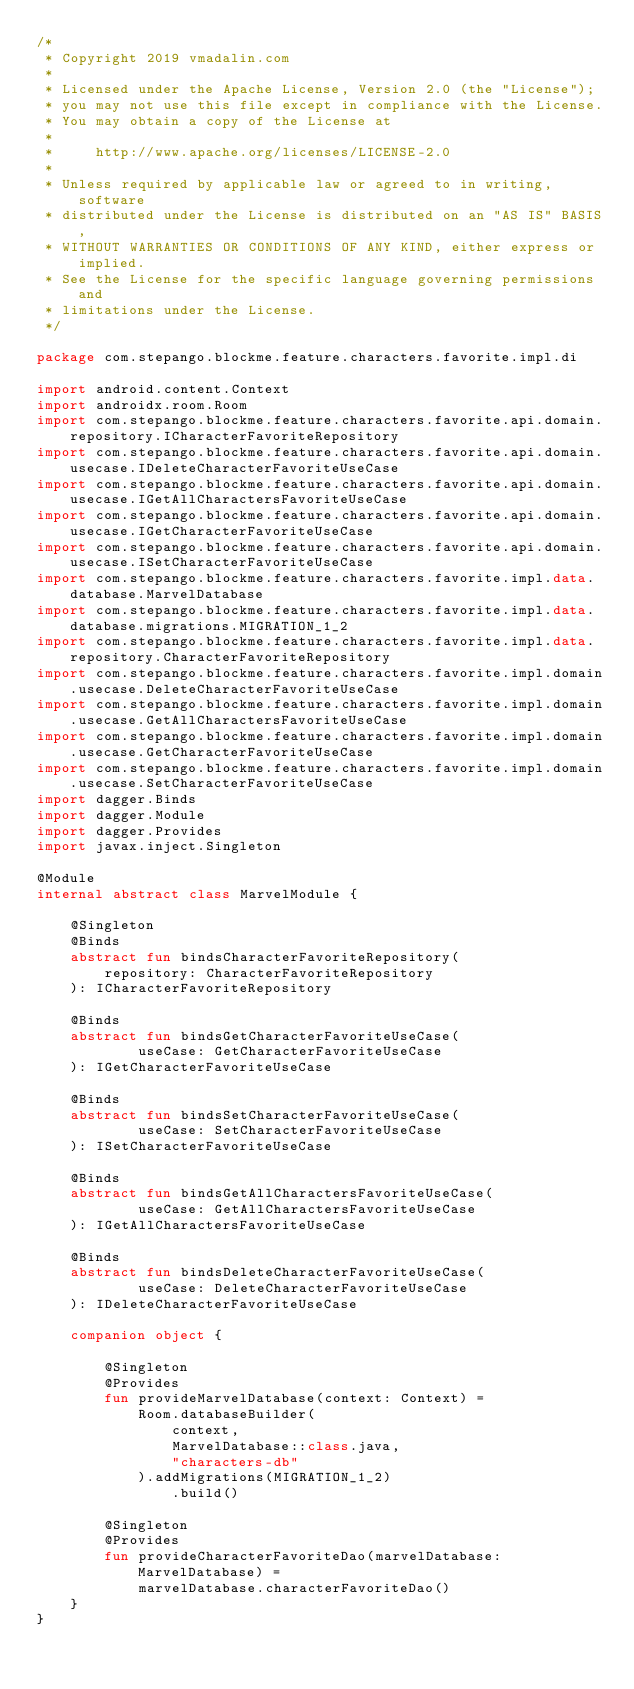Convert code to text. <code><loc_0><loc_0><loc_500><loc_500><_Kotlin_>/*
 * Copyright 2019 vmadalin.com
 *
 * Licensed under the Apache License, Version 2.0 (the "License");
 * you may not use this file except in compliance with the License.
 * You may obtain a copy of the License at
 *
 *     http://www.apache.org/licenses/LICENSE-2.0
 *
 * Unless required by applicable law or agreed to in writing, software
 * distributed under the License is distributed on an "AS IS" BASIS,
 * WITHOUT WARRANTIES OR CONDITIONS OF ANY KIND, either express or implied.
 * See the License for the specific language governing permissions and
 * limitations under the License.
 */

package com.stepango.blockme.feature.characters.favorite.impl.di

import android.content.Context
import androidx.room.Room
import com.stepango.blockme.feature.characters.favorite.api.domain.repository.ICharacterFavoriteRepository
import com.stepango.blockme.feature.characters.favorite.api.domain.usecase.IDeleteCharacterFavoriteUseCase
import com.stepango.blockme.feature.characters.favorite.api.domain.usecase.IGetAllCharactersFavoriteUseCase
import com.stepango.blockme.feature.characters.favorite.api.domain.usecase.IGetCharacterFavoriteUseCase
import com.stepango.blockme.feature.characters.favorite.api.domain.usecase.ISetCharacterFavoriteUseCase
import com.stepango.blockme.feature.characters.favorite.impl.data.database.MarvelDatabase
import com.stepango.blockme.feature.characters.favorite.impl.data.database.migrations.MIGRATION_1_2
import com.stepango.blockme.feature.characters.favorite.impl.data.repository.CharacterFavoriteRepository
import com.stepango.blockme.feature.characters.favorite.impl.domain.usecase.DeleteCharacterFavoriteUseCase
import com.stepango.blockme.feature.characters.favorite.impl.domain.usecase.GetAllCharactersFavoriteUseCase
import com.stepango.blockme.feature.characters.favorite.impl.domain.usecase.GetCharacterFavoriteUseCase
import com.stepango.blockme.feature.characters.favorite.impl.domain.usecase.SetCharacterFavoriteUseCase
import dagger.Binds
import dagger.Module
import dagger.Provides
import javax.inject.Singleton

@Module
internal abstract class MarvelModule {

    @Singleton
    @Binds
    abstract fun bindsCharacterFavoriteRepository(
        repository: CharacterFavoriteRepository
    ): ICharacterFavoriteRepository

    @Binds
    abstract fun bindsGetCharacterFavoriteUseCase(
            useCase: GetCharacterFavoriteUseCase
    ): IGetCharacterFavoriteUseCase

    @Binds
    abstract fun bindsSetCharacterFavoriteUseCase(
            useCase: SetCharacterFavoriteUseCase
    ): ISetCharacterFavoriteUseCase

    @Binds
    abstract fun bindsGetAllCharactersFavoriteUseCase(
            useCase: GetAllCharactersFavoriteUseCase
    ): IGetAllCharactersFavoriteUseCase

    @Binds
    abstract fun bindsDeleteCharacterFavoriteUseCase(
            useCase: DeleteCharacterFavoriteUseCase
    ): IDeleteCharacterFavoriteUseCase

    companion object {

        @Singleton
        @Provides
        fun provideMarvelDatabase(context: Context) =
            Room.databaseBuilder(
                context,
                MarvelDatabase::class.java,
                "characters-db"
            ).addMigrations(MIGRATION_1_2)
                .build()

        @Singleton
        @Provides
        fun provideCharacterFavoriteDao(marvelDatabase: MarvelDatabase) =
            marvelDatabase.characterFavoriteDao()
    }
}
</code> 